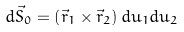Convert formula to latex. <formula><loc_0><loc_0><loc_500><loc_500>d \vec { S } _ { 0 } = \left ( \vec { r } _ { 1 } \times \vec { r } _ { 2 } \right ) d u _ { 1 } d u _ { 2 }</formula> 